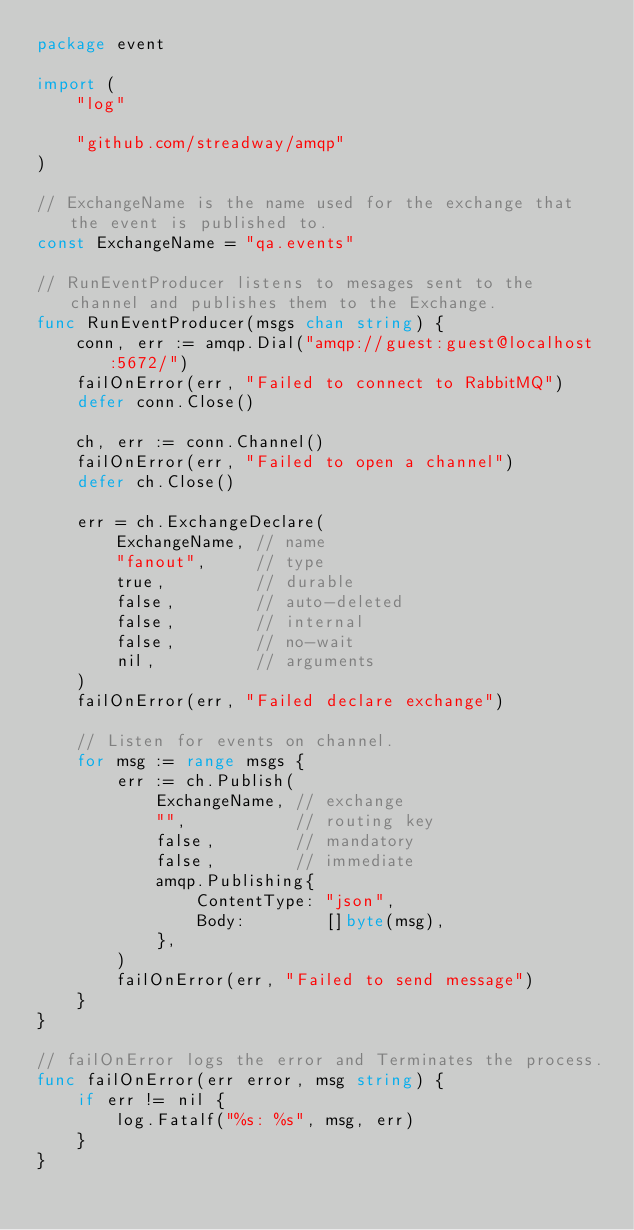<code> <loc_0><loc_0><loc_500><loc_500><_Go_>package event

import (
	"log"

	"github.com/streadway/amqp"
)

// ExchangeName is the name used for the exchange that the event is published to.
const ExchangeName = "qa.events"

// RunEventProducer listens to mesages sent to the channel and publishes them to the Exchange.
func RunEventProducer(msgs chan string) {
	conn, err := amqp.Dial("amqp://guest:guest@localhost:5672/")
	failOnError(err, "Failed to connect to RabbitMQ")
	defer conn.Close()

	ch, err := conn.Channel()
	failOnError(err, "Failed to open a channel")
	defer ch.Close()

	err = ch.ExchangeDeclare(
		ExchangeName, // name
		"fanout",     // type
		true,         // durable
		false,        // auto-deleted
		false,        // internal
		false,        // no-wait
		nil,          // arguments
	)
	failOnError(err, "Failed declare exchange")

	// Listen for events on channel.
	for msg := range msgs {
		err := ch.Publish(
			ExchangeName, // exchange
			"",           // routing key
			false,        // mandatory
			false,        // immediate
			amqp.Publishing{
				ContentType: "json",
				Body:        []byte(msg),
			},
		)
		failOnError(err, "Failed to send message")
	}
}

// failOnError logs the error and Terminates the process.
func failOnError(err error, msg string) {
	if err != nil {
		log.Fatalf("%s: %s", msg, err)
	}
}
</code> 